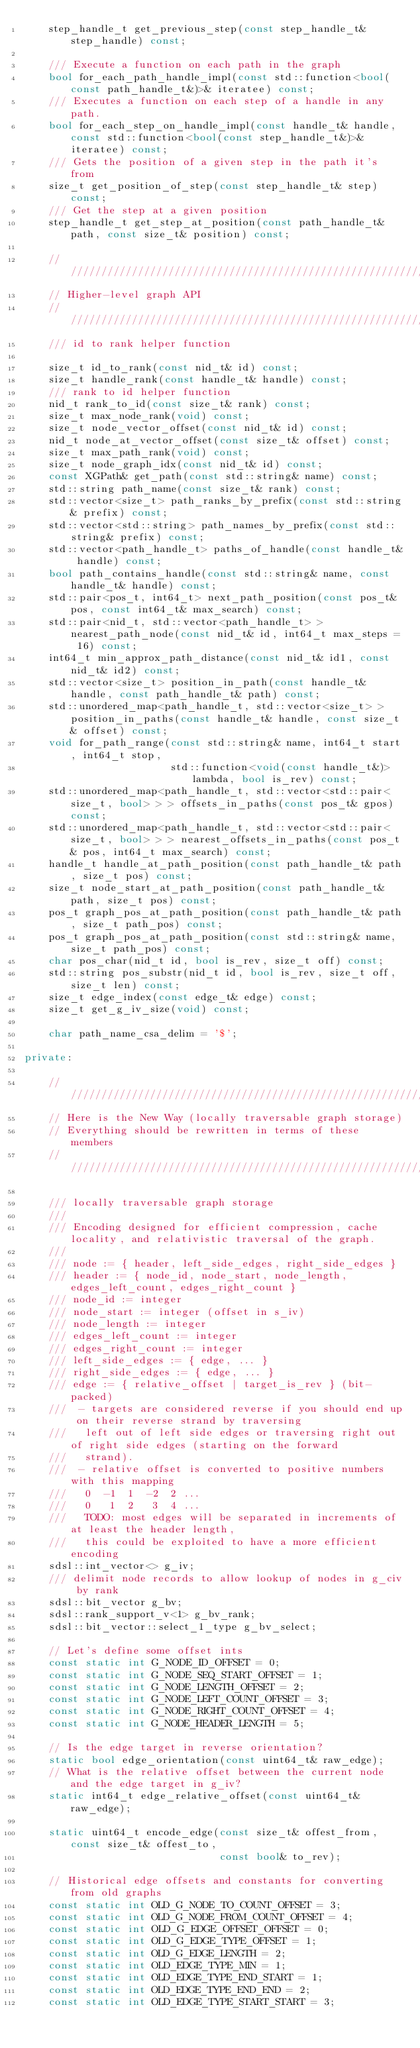Convert code to text. <code><loc_0><loc_0><loc_500><loc_500><_C++_>    step_handle_t get_previous_step(const step_handle_t& step_handle) const;
    
    /// Execute a function on each path in the graph
    bool for_each_path_handle_impl(const std::function<bool(const path_handle_t&)>& iteratee) const;
    /// Executes a function on each step of a handle in any path.
    bool for_each_step_on_handle_impl(const handle_t& handle, const std::function<bool(const step_handle_t&)>& iteratee) const;
    /// Gets the position of a given step in the path it's from
    size_t get_position_of_step(const step_handle_t& step) const;
    /// Get the step at a given position
    step_handle_t get_step_at_position(const path_handle_t& path, const size_t& position) const;
    
    ////////////////////////////////////////////////////////////////////////////
    // Higher-level graph API
    ////////////////////////////////////////////////////////////////////////////
    /// id to rank helper function

    size_t id_to_rank(const nid_t& id) const;
    size_t handle_rank(const handle_t& handle) const;
    /// rank to id helper function
    nid_t rank_to_id(const size_t& rank) const;
    size_t max_node_rank(void) const;
    size_t node_vector_offset(const nid_t& id) const;
    nid_t node_at_vector_offset(const size_t& offset) const;
    size_t max_path_rank(void) const;
    size_t node_graph_idx(const nid_t& id) const;
    const XGPath& get_path(const std::string& name) const;
    std::string path_name(const size_t& rank) const;
    std::vector<size_t> path_ranks_by_prefix(const std::string& prefix) const;
    std::vector<std::string> path_names_by_prefix(const std::string& prefix) const;
    std::vector<path_handle_t> paths_of_handle(const handle_t& handle) const;
    bool path_contains_handle(const std::string& name, const handle_t& handle) const;
    std::pair<pos_t, int64_t> next_path_position(const pos_t& pos, const int64_t& max_search) const;
    std::pair<nid_t, std::vector<path_handle_t> > nearest_path_node(const nid_t& id, int64_t max_steps = 16) const;
    int64_t min_approx_path_distance(const nid_t& id1, const nid_t& id2) const;
    std::vector<size_t> position_in_path(const handle_t& handle, const path_handle_t& path) const;
    std::unordered_map<path_handle_t, std::vector<size_t> > position_in_paths(const handle_t& handle, const size_t& offset) const;
    void for_path_range(const std::string& name, int64_t start, int64_t stop,
                        std::function<void(const handle_t&)> lambda, bool is_rev) const;
    std::unordered_map<path_handle_t, std::vector<std::pair<size_t, bool> > > offsets_in_paths(const pos_t& gpos) const;
    std::unordered_map<path_handle_t, std::vector<std::pair<size_t, bool> > > nearest_offsets_in_paths(const pos_t& pos, int64_t max_search) const;
    handle_t handle_at_path_position(const path_handle_t& path, size_t pos) const;
    size_t node_start_at_path_position(const path_handle_t& path, size_t pos) const;
    pos_t graph_pos_at_path_position(const path_handle_t& path, size_t path_pos) const;
    pos_t graph_pos_at_path_position(const std::string& name, size_t path_pos) const;
    char pos_char(nid_t id, bool is_rev, size_t off) const;
    std::string pos_substr(nid_t id, bool is_rev, size_t off, size_t len) const;
    size_t edge_index(const edge_t& edge) const;
    size_t get_g_iv_size(void) const;

    char path_name_csa_delim = '$';

private:

    ////////////////////////////////////////////////////////////////////////////
    // Here is the New Way (locally traversable graph storage)
    // Everything should be rewritten in terms of these members
    ////////////////////////////////////////////////////////////////////////////

    /// locally traversable graph storage
    ///
    /// Encoding designed for efficient compression, cache locality, and relativistic traversal of the graph.
    ///
    /// node := { header, left_side_edges, right_side_edges }
    /// header := { node_id, node_start, node_length, edges_left_count, edges_right_count }
    /// node_id := integer
    /// node_start := integer (offset in s_iv)
    /// node_length := integer
    /// edges_left_count := integer
    /// edges_right_count := integer
    /// left_side_edges := { edge, ... }
    /// right_side_edges := { edge, ... }
    /// edge := { relative_offset | target_is_rev } (bit-packed)
    ///  - targets are considered reverse if you should end up on their reverse strand by traversing
    ///   left out of left side edges or traversing right out of right side edges (starting on the forward
    ///   strand).
    ///  - relative offset is converted to positive numbers with this mapping
    ///   0  -1  1  -2  2 ...
    ///   0   1  2   3  4 ...
    ///   TODO: most edges will be separated in increments of at least the header length,
    ///   this could be exploited to have a more efficient encoding
    sdsl::int_vector<> g_iv;
    /// delimit node records to allow lookup of nodes in g_civ by rank
    sdsl::bit_vector g_bv;
    sdsl::rank_support_v<1> g_bv_rank;
    sdsl::bit_vector::select_1_type g_bv_select;
    
    // Let's define some offset ints
    const static int G_NODE_ID_OFFSET = 0;
    const static int G_NODE_SEQ_START_OFFSET = 1;
    const static int G_NODE_LENGTH_OFFSET = 2;
    const static int G_NODE_LEFT_COUNT_OFFSET = 3;
    const static int G_NODE_RIGHT_COUNT_OFFSET = 4;
    const static int G_NODE_HEADER_LENGTH = 5;
    
    // Is the edge target in reverse orientation?
    static bool edge_orientation(const uint64_t& raw_edge);
    // What is the relative offset between the current node and the edge target in g_iv?
    static int64_t edge_relative_offset(const uint64_t& raw_edge);
    
    static uint64_t encode_edge(const size_t& offest_from, const size_t& offest_to,
                                const bool& to_rev);
    
    // Historical edge offsets and constants for converting from old graphs
    const static int OLD_G_NODE_TO_COUNT_OFFSET = 3;
    const static int OLD_G_NODE_FROM_COUNT_OFFSET = 4;
    const static int OLD_G_EDGE_OFFSET_OFFSET = 0;
    const static int OLD_G_EDGE_TYPE_OFFSET = 1;
    const static int OLD_G_EDGE_LENGTH = 2;
    const static int OLD_EDGE_TYPE_MIN = 1;
    const static int OLD_EDGE_TYPE_END_START = 1;
    const static int OLD_EDGE_TYPE_END_END = 2;
    const static int OLD_EDGE_TYPE_START_START = 3;</code> 